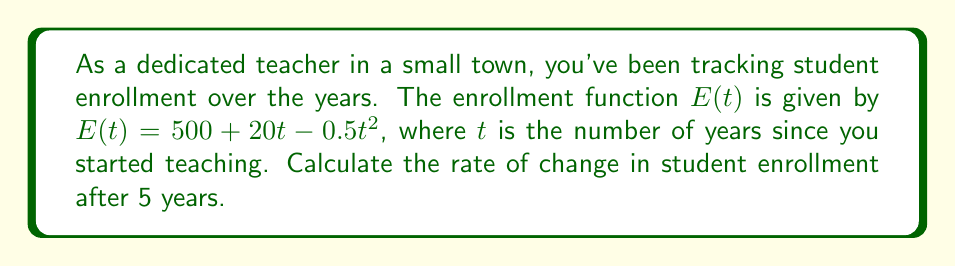Solve this math problem. To find the rate of change in student enrollment after 5 years, we need to calculate the derivative of the enrollment function $E(t)$ and evaluate it at $t=5$. Let's break this down step-by-step:

1. Given enrollment function: $E(t) = 500 + 20t - 0.5t^2$

2. Calculate the derivative $E'(t)$:
   - The derivative of a constant (500) is 0
   - The derivative of $20t$ is 20
   - The derivative of $-0.5t^2$ is $-0.5 \cdot 2t = -t$

   Therefore, $E'(t) = 0 + 20 - t = 20 - t$

3. Evaluate $E'(t)$ at $t=5$:
   $E'(5) = 20 - 5 = 15$

The rate of change is given by the value of the derivative at the specified point in time.
Answer: 15 students per year 